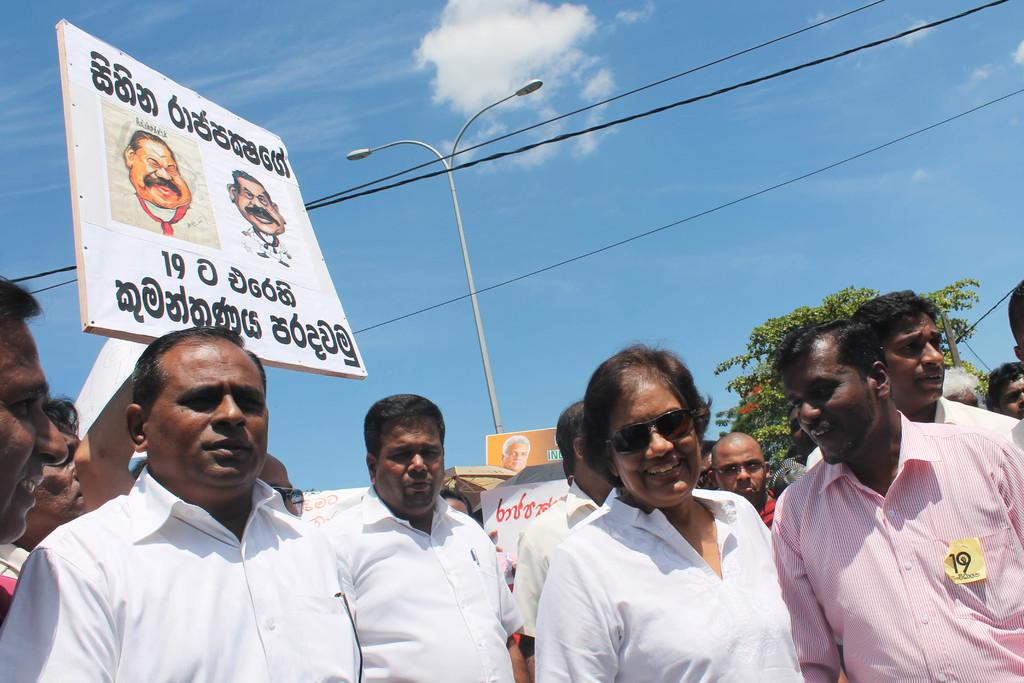What are the men in the image doing? The men are protesting. What are the men holding in the image? The men are holding banners. What can be seen in the background of the image? There are poles, wires, trees, and the sky visible in the background of the image. What type of pest can be seen crawling on the banners in the image? There are no pests visible in the image; the men are holding banners with messages or slogans. 